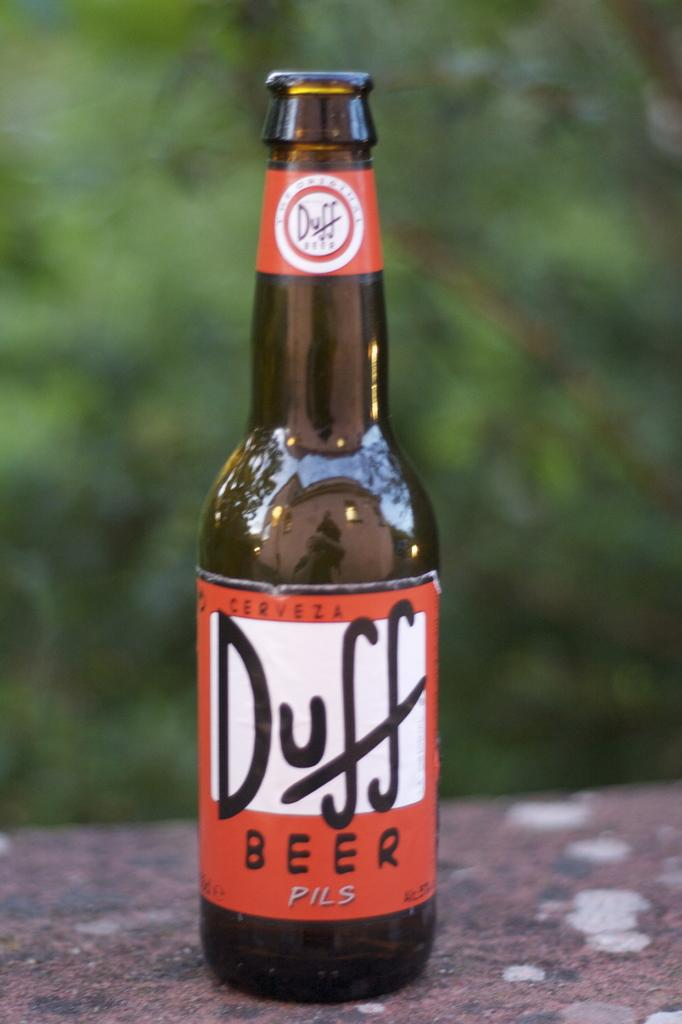Provide a one-sentence caption for the provided image. An open bottle of Duff beer which is a pils. 